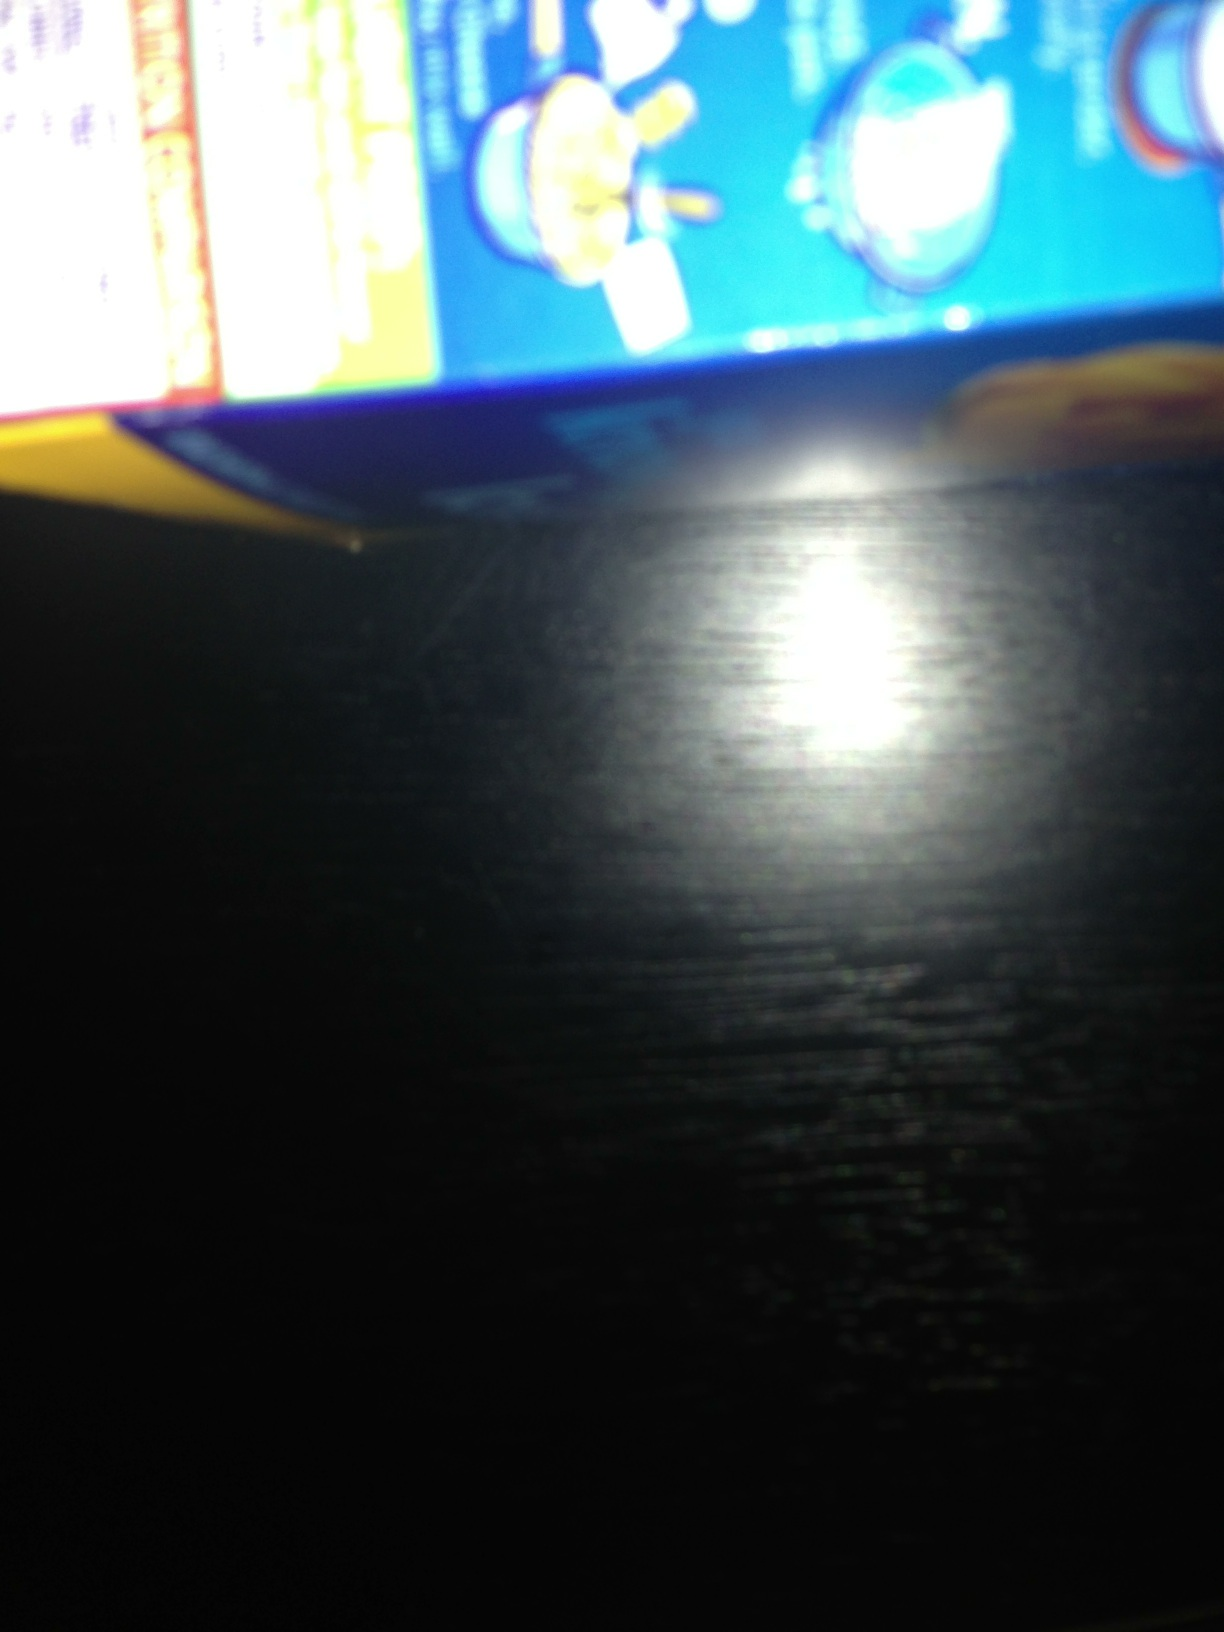Can you describe the cooking instructions on this box? Based on the visible part of the image, it seems the box contains step-by-step cooking instructions illustrated with pictures. However, the image is blurry, making it difficult to read the exact text. Please retake the photo ensuring it's clear and focused. What tips can you provide for taking clear images of text on boxes like this? To take clear pictures of text on boxes: 1. Ensure good lighting, preferably natural light. 2. Hold your camera or phone steady and close to the text. 3. Use the focus feature to make sure the text is clear. 4. Avoid using flash directly as it can create glare. 5. If possible, use a camera with a macro lens to capture small details. 